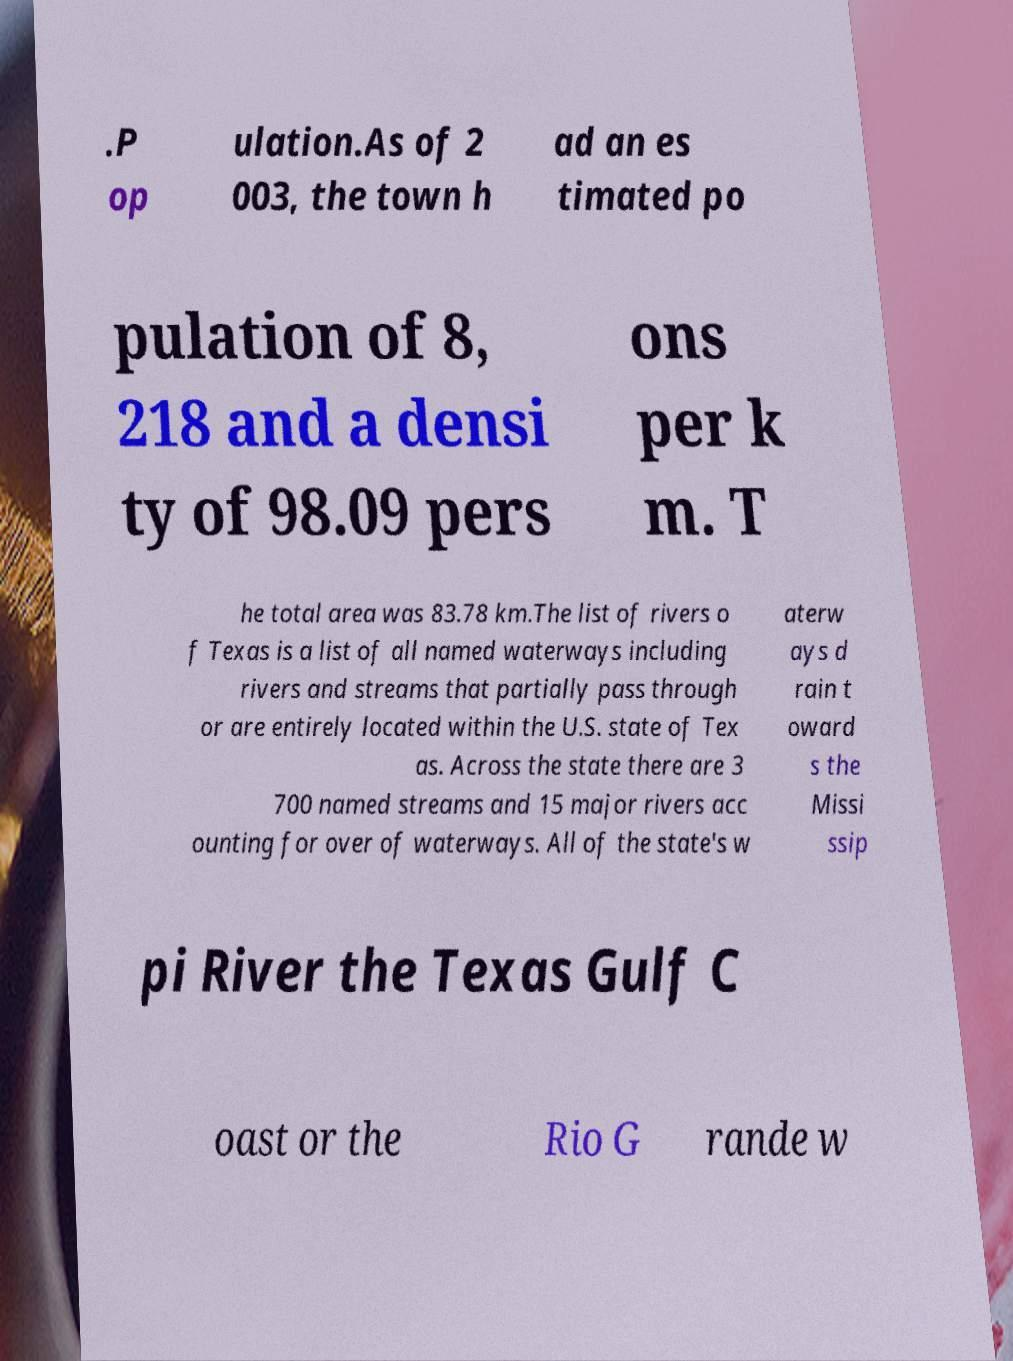Can you read and provide the text displayed in the image?This photo seems to have some interesting text. Can you extract and type it out for me? .P op ulation.As of 2 003, the town h ad an es timated po pulation of 8, 218 and a densi ty of 98.09 pers ons per k m. T he total area was 83.78 km.The list of rivers o f Texas is a list of all named waterways including rivers and streams that partially pass through or are entirely located within the U.S. state of Tex as. Across the state there are 3 700 named streams and 15 major rivers acc ounting for over of waterways. All of the state's w aterw ays d rain t oward s the Missi ssip pi River the Texas Gulf C oast or the Rio G rande w 